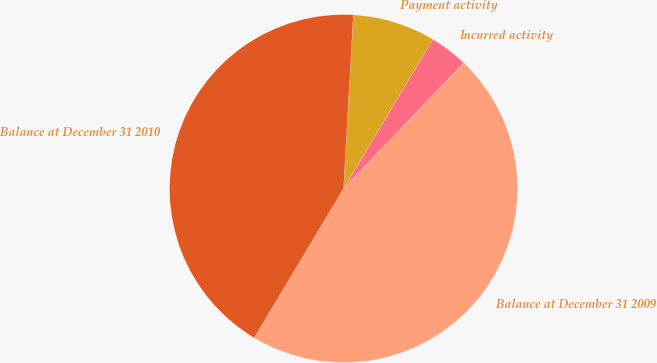Convert chart. <chart><loc_0><loc_0><loc_500><loc_500><pie_chart><fcel>Balance at December 31 2009<fcel>Incurred activity<fcel>Payment activity<fcel>Balance at December 31 2010<nl><fcel>46.45%<fcel>3.55%<fcel>7.69%<fcel>42.31%<nl></chart> 